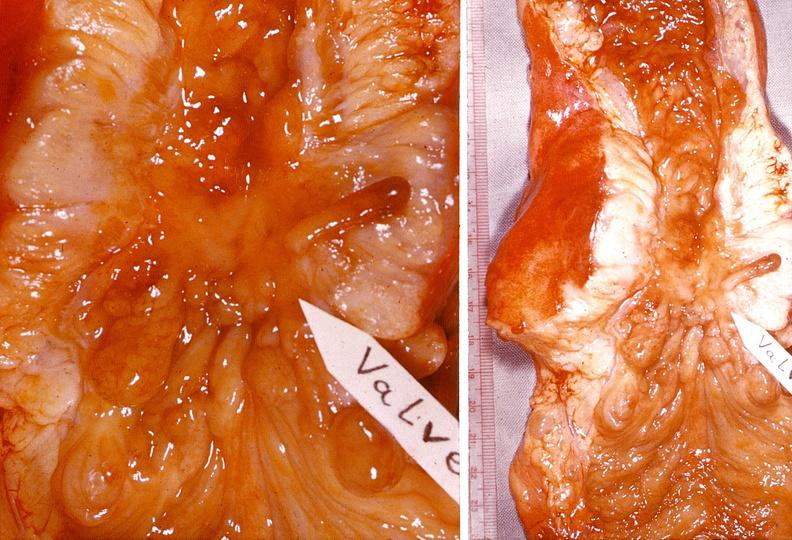s gastrointestinal present?
Answer the question using a single word or phrase. Yes 